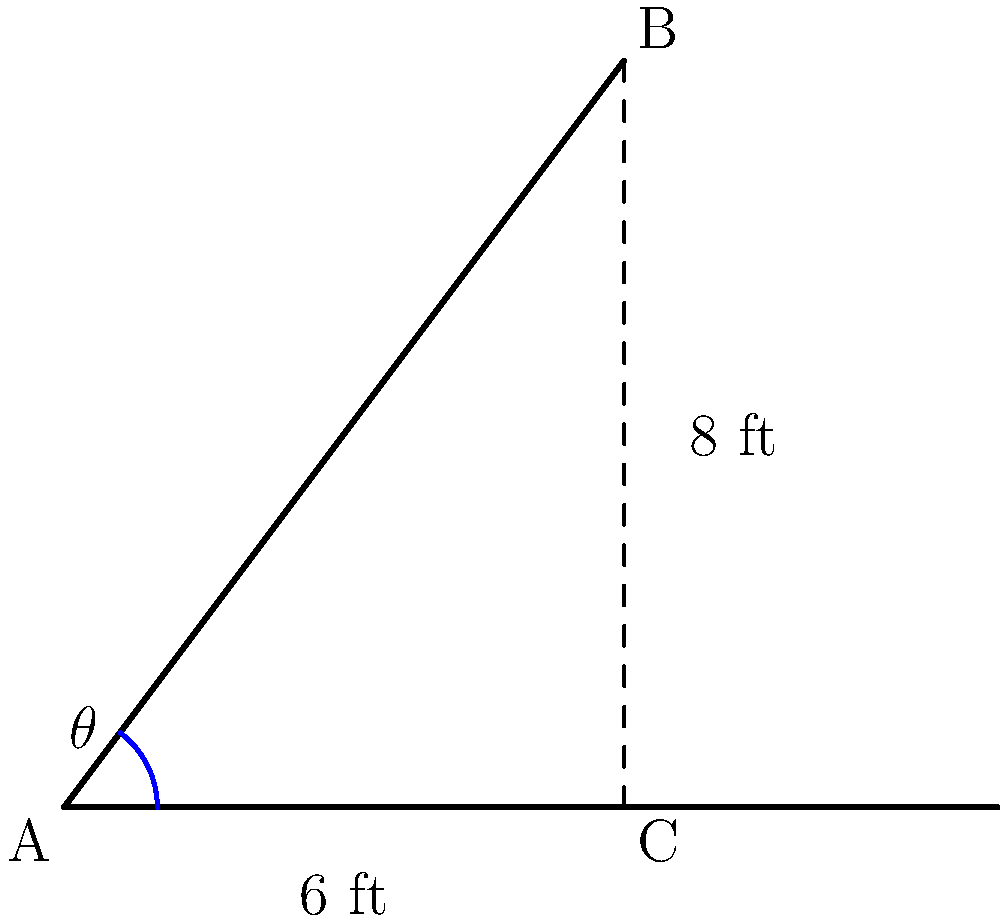You're designing a cat tree for your feline companion, aiming to create the perfect climbing angle for maximum comfort. The base of the cat tree is 6 feet long, and the top reaches a height of 8 feet. Using the tangent function, calculate the angle $\theta$ (in degrees) between the cat tree and the floor to ensure optimal climbing comfort for your cat. Let's approach this step-by-step:

1) In this scenario, we have a right triangle where:
   - The adjacent side (base) is 6 feet
   - The opposite side (height) is 8 feet
   - We need to find the angle $\theta$

2) The tangent of an angle in a right triangle is defined as the ratio of the opposite side to the adjacent side:

   $\tan(\theta) = \frac{\text{opposite}}{\text{adjacent}}$

3) Plugging in our values:

   $\tan(\theta) = \frac{8}{6}$

4) Simplify the fraction:

   $\tan(\theta) = \frac{4}{3}$

5) To find $\theta$, we need to use the inverse tangent (arctan or $\tan^{-1}$) function:

   $\theta = \tan^{-1}(\frac{4}{3})$

6) Using a calculator or trigonometric tables:

   $\theta \approx 53.13^\circ$

7) Round to the nearest degree:

   $\theta \approx 53^\circ$

Therefore, the angle between the cat tree and the floor should be approximately 53° for optimal climbing comfort.
Answer: $53^\circ$ 